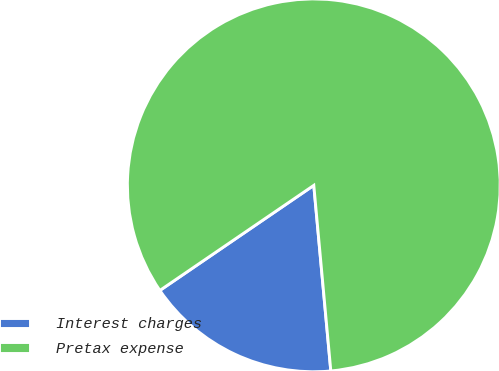<chart> <loc_0><loc_0><loc_500><loc_500><pie_chart><fcel>Interest charges<fcel>Pretax expense<nl><fcel>16.92%<fcel>83.08%<nl></chart> 